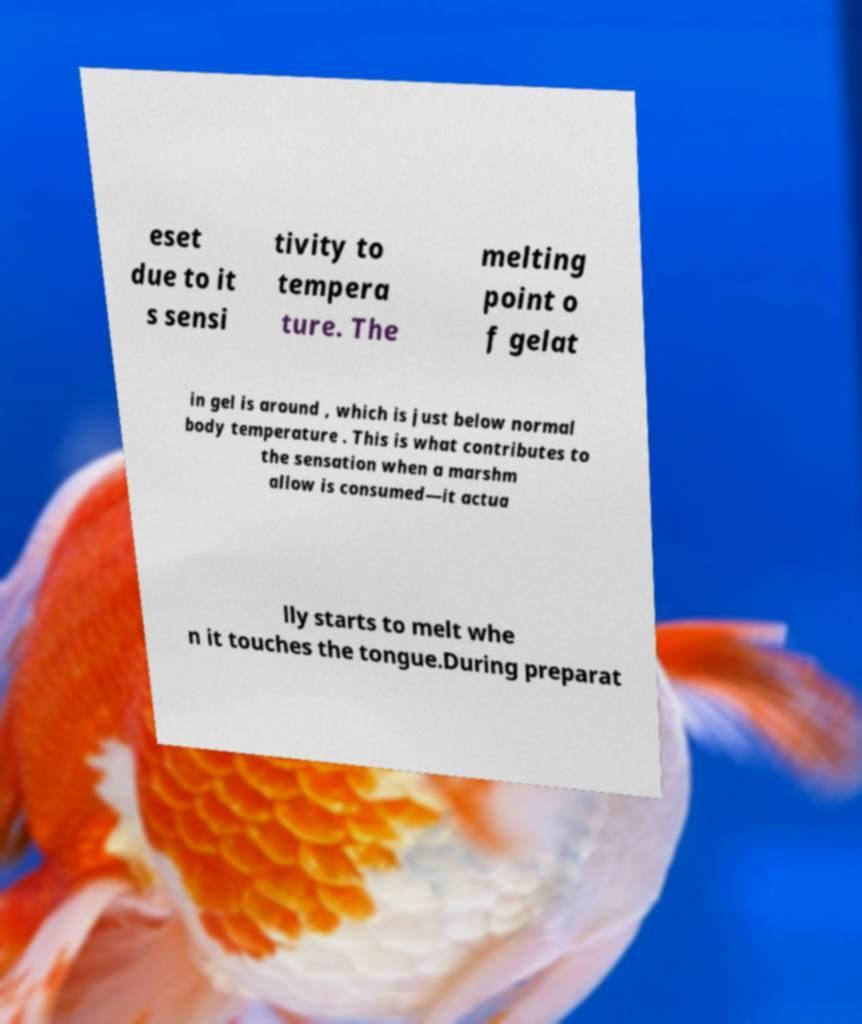Please identify and transcribe the text found in this image. eset due to it s sensi tivity to tempera ture. The melting point o f gelat in gel is around , which is just below normal body temperature . This is what contributes to the sensation when a marshm allow is consumed—it actua lly starts to melt whe n it touches the tongue.During preparat 